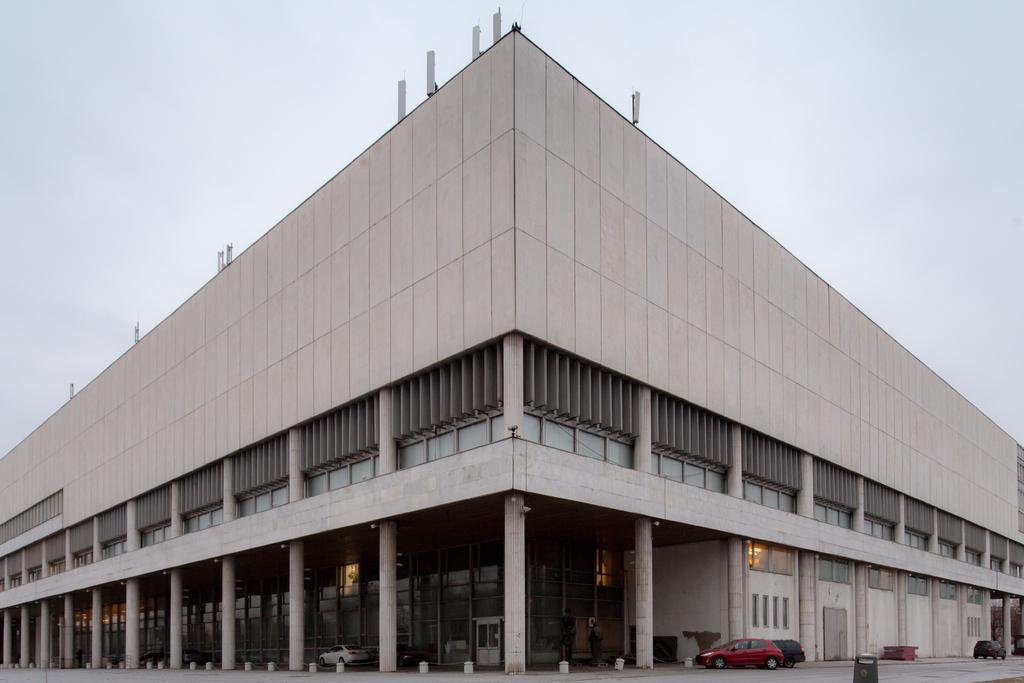Could you give a brief overview of what you see in this image? In the picture we can see the building with the pillars under it and we can see some vehicles are parked near it and in the background we can see the sky. 